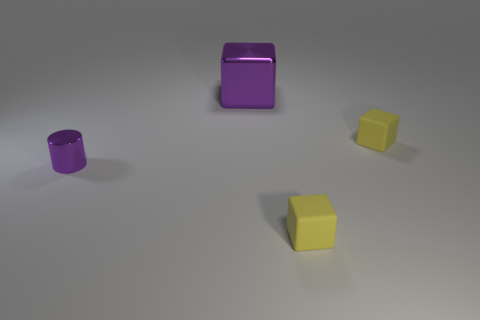What number of other things are there of the same shape as the small metal thing?
Provide a short and direct response. 0. Does the purple cylinder have the same size as the purple block?
Keep it short and to the point. No. Is the number of small yellow matte objects in front of the metal cube greater than the number of purple things behind the metal cylinder?
Provide a succinct answer. Yes. How many other things are there of the same size as the metal cube?
Keep it short and to the point. 0. Does the shiny thing that is behind the purple metallic cylinder have the same color as the tiny metallic cylinder?
Ensure brevity in your answer.  Yes. Is the number of purple metal objects to the left of the large thing greater than the number of brown rubber objects?
Your response must be concise. Yes. There is a tiny yellow rubber object behind the thing on the left side of the large purple shiny cube; what shape is it?
Make the answer very short. Cube. Are there more purple shiny cubes than blue blocks?
Offer a terse response. Yes. What number of things are both right of the purple metallic cylinder and left of the large purple cube?
Offer a terse response. 0. What number of tiny metallic cylinders are behind the cube in front of the tiny purple cylinder?
Provide a short and direct response. 1. 